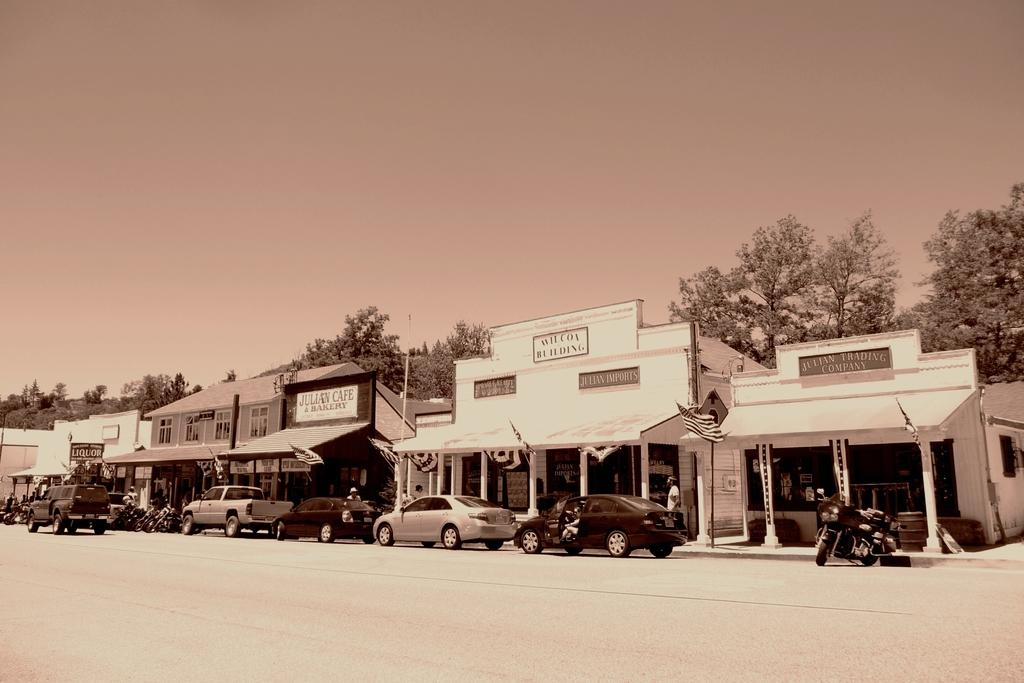What is the main subject of the image? The main subject of the image is vehicles on a road. What can be seen in the background of the image? There are buildings, trees, and the sky visible in the background of the image. What type of vein is visible in the image? There are no veins visible in the image; it features vehicles on a road with a background of buildings, trees, and the sky. 